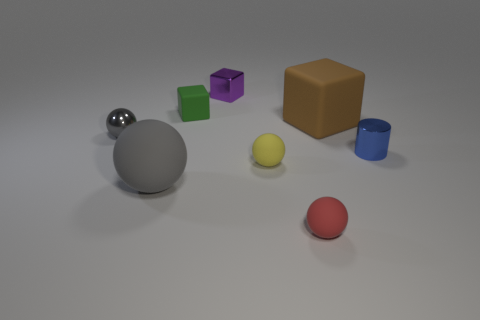Does the metal ball have the same color as the big ball?
Make the answer very short. Yes. There is a rubber object that is the same color as the metal ball; what is its size?
Your response must be concise. Large. There is a large object that is the same color as the metal sphere; what is its material?
Ensure brevity in your answer.  Rubber. Does the big object to the left of the purple metal cube have the same color as the tiny metallic ball?
Make the answer very short. Yes. What number of other objects are there of the same color as the large ball?
Keep it short and to the point. 1. How many things are either small yellow things or cylinders?
Offer a terse response. 2. What number of things are either tiny red matte objects or things that are in front of the large matte cube?
Ensure brevity in your answer.  5. Does the small blue cylinder have the same material as the yellow sphere?
Keep it short and to the point. No. What number of other objects are the same material as the purple object?
Provide a succinct answer. 2. Is the number of red rubber things greater than the number of large blue objects?
Offer a terse response. Yes. 